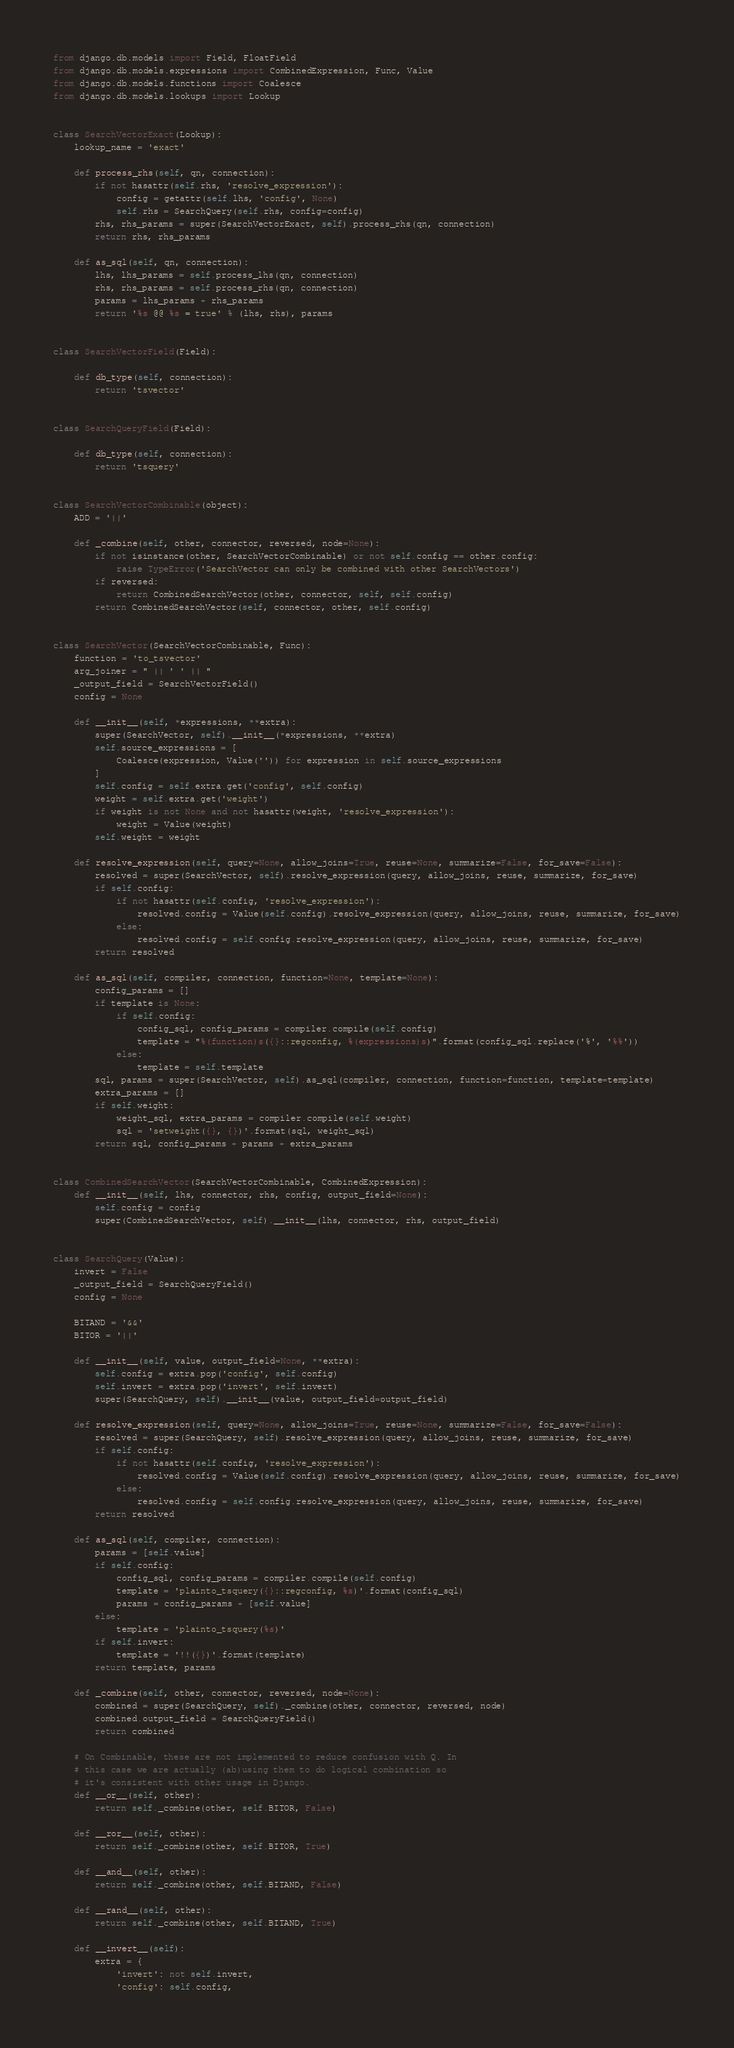<code> <loc_0><loc_0><loc_500><loc_500><_Python_>from django.db.models import Field, FloatField
from django.db.models.expressions import CombinedExpression, Func, Value
from django.db.models.functions import Coalesce
from django.db.models.lookups import Lookup


class SearchVectorExact(Lookup):
    lookup_name = 'exact'

    def process_rhs(self, qn, connection):
        if not hasattr(self.rhs, 'resolve_expression'):
            config = getattr(self.lhs, 'config', None)
            self.rhs = SearchQuery(self.rhs, config=config)
        rhs, rhs_params = super(SearchVectorExact, self).process_rhs(qn, connection)
        return rhs, rhs_params

    def as_sql(self, qn, connection):
        lhs, lhs_params = self.process_lhs(qn, connection)
        rhs, rhs_params = self.process_rhs(qn, connection)
        params = lhs_params + rhs_params
        return '%s @@ %s = true' % (lhs, rhs), params


class SearchVectorField(Field):

    def db_type(self, connection):
        return 'tsvector'


class SearchQueryField(Field):

    def db_type(self, connection):
        return 'tsquery'


class SearchVectorCombinable(object):
    ADD = '||'

    def _combine(self, other, connector, reversed, node=None):
        if not isinstance(other, SearchVectorCombinable) or not self.config == other.config:
            raise TypeError('SearchVector can only be combined with other SearchVectors')
        if reversed:
            return CombinedSearchVector(other, connector, self, self.config)
        return CombinedSearchVector(self, connector, other, self.config)


class SearchVector(SearchVectorCombinable, Func):
    function = 'to_tsvector'
    arg_joiner = " || ' ' || "
    _output_field = SearchVectorField()
    config = None

    def __init__(self, *expressions, **extra):
        super(SearchVector, self).__init__(*expressions, **extra)
        self.source_expressions = [
            Coalesce(expression, Value('')) for expression in self.source_expressions
        ]
        self.config = self.extra.get('config', self.config)
        weight = self.extra.get('weight')
        if weight is not None and not hasattr(weight, 'resolve_expression'):
            weight = Value(weight)
        self.weight = weight

    def resolve_expression(self, query=None, allow_joins=True, reuse=None, summarize=False, for_save=False):
        resolved = super(SearchVector, self).resolve_expression(query, allow_joins, reuse, summarize, for_save)
        if self.config:
            if not hasattr(self.config, 'resolve_expression'):
                resolved.config = Value(self.config).resolve_expression(query, allow_joins, reuse, summarize, for_save)
            else:
                resolved.config = self.config.resolve_expression(query, allow_joins, reuse, summarize, for_save)
        return resolved

    def as_sql(self, compiler, connection, function=None, template=None):
        config_params = []
        if template is None:
            if self.config:
                config_sql, config_params = compiler.compile(self.config)
                template = "%(function)s({}::regconfig, %(expressions)s)".format(config_sql.replace('%', '%%'))
            else:
                template = self.template
        sql, params = super(SearchVector, self).as_sql(compiler, connection, function=function, template=template)
        extra_params = []
        if self.weight:
            weight_sql, extra_params = compiler.compile(self.weight)
            sql = 'setweight({}, {})'.format(sql, weight_sql)
        return sql, config_params + params + extra_params


class CombinedSearchVector(SearchVectorCombinable, CombinedExpression):
    def __init__(self, lhs, connector, rhs, config, output_field=None):
        self.config = config
        super(CombinedSearchVector, self).__init__(lhs, connector, rhs, output_field)


class SearchQuery(Value):
    invert = False
    _output_field = SearchQueryField()
    config = None

    BITAND = '&&'
    BITOR = '||'

    def __init__(self, value, output_field=None, **extra):
        self.config = extra.pop('config', self.config)
        self.invert = extra.pop('invert', self.invert)
        super(SearchQuery, self).__init__(value, output_field=output_field)

    def resolve_expression(self, query=None, allow_joins=True, reuse=None, summarize=False, for_save=False):
        resolved = super(SearchQuery, self).resolve_expression(query, allow_joins, reuse, summarize, for_save)
        if self.config:
            if not hasattr(self.config, 'resolve_expression'):
                resolved.config = Value(self.config).resolve_expression(query, allow_joins, reuse, summarize, for_save)
            else:
                resolved.config = self.config.resolve_expression(query, allow_joins, reuse, summarize, for_save)
        return resolved

    def as_sql(self, compiler, connection):
        params = [self.value]
        if self.config:
            config_sql, config_params = compiler.compile(self.config)
            template = 'plainto_tsquery({}::regconfig, %s)'.format(config_sql)
            params = config_params + [self.value]
        else:
            template = 'plainto_tsquery(%s)'
        if self.invert:
            template = '!!({})'.format(template)
        return template, params

    def _combine(self, other, connector, reversed, node=None):
        combined = super(SearchQuery, self)._combine(other, connector, reversed, node)
        combined.output_field = SearchQueryField()
        return combined

    # On Combinable, these are not implemented to reduce confusion with Q. In
    # this case we are actually (ab)using them to do logical combination so
    # it's consistent with other usage in Django.
    def __or__(self, other):
        return self._combine(other, self.BITOR, False)

    def __ror__(self, other):
        return self._combine(other, self.BITOR, True)

    def __and__(self, other):
        return self._combine(other, self.BITAND, False)

    def __rand__(self, other):
        return self._combine(other, self.BITAND, True)

    def __invert__(self):
        extra = {
            'invert': not self.invert,
            'config': self.config,</code> 